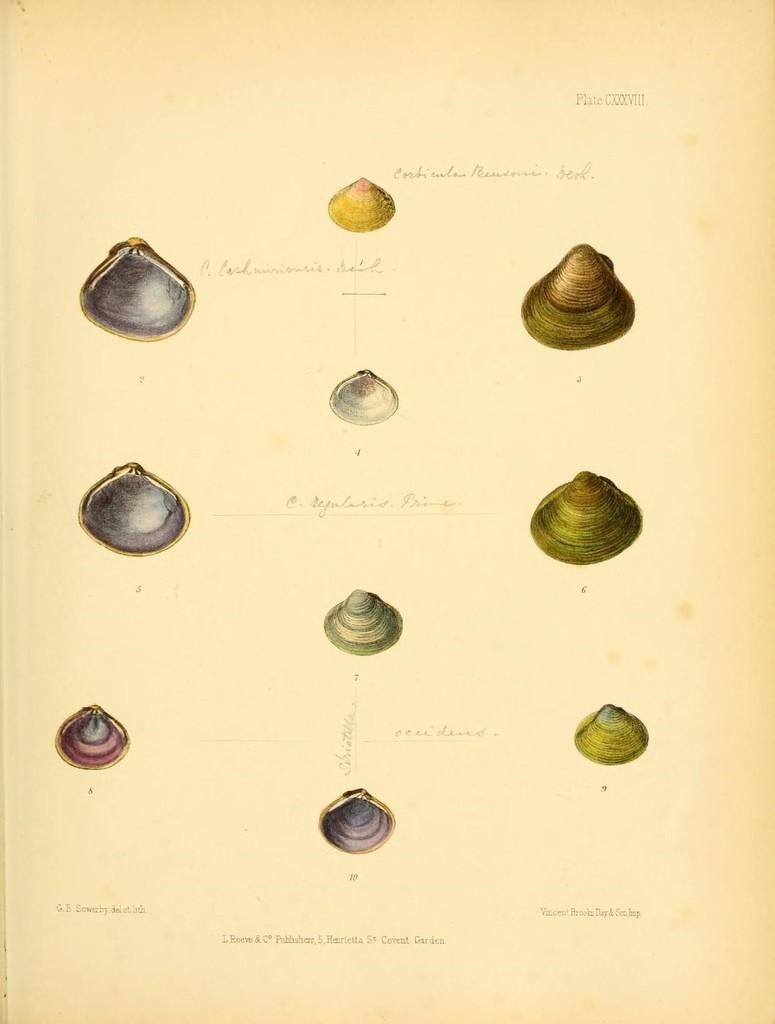What is present in the image related to paper? There is a paper in the image. What is depicted on the paper? The paper contains an art of shells. Are there any words or letters on the paper? Yes, there is text on the paper. How does the tent move in the image? There is no tent present in the image. 